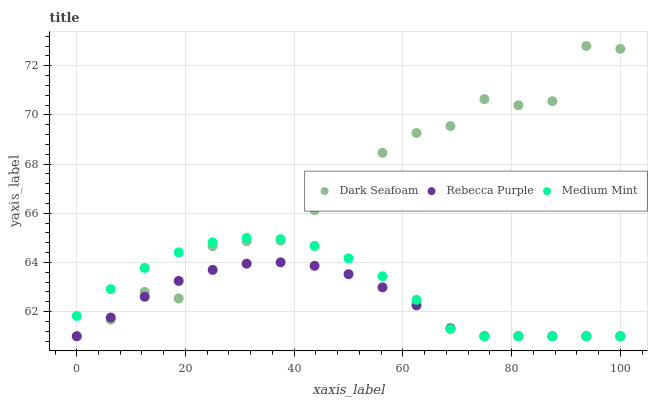Does Rebecca Purple have the minimum area under the curve?
Answer yes or no. Yes. Does Dark Seafoam have the maximum area under the curve?
Answer yes or no. Yes. Does Dark Seafoam have the minimum area under the curve?
Answer yes or no. No. Does Rebecca Purple have the maximum area under the curve?
Answer yes or no. No. Is Rebecca Purple the smoothest?
Answer yes or no. Yes. Is Dark Seafoam the roughest?
Answer yes or no. Yes. Is Dark Seafoam the smoothest?
Answer yes or no. No. Is Rebecca Purple the roughest?
Answer yes or no. No. Does Medium Mint have the lowest value?
Answer yes or no. Yes. Does Dark Seafoam have the highest value?
Answer yes or no. Yes. Does Rebecca Purple have the highest value?
Answer yes or no. No. Does Dark Seafoam intersect Medium Mint?
Answer yes or no. Yes. Is Dark Seafoam less than Medium Mint?
Answer yes or no. No. Is Dark Seafoam greater than Medium Mint?
Answer yes or no. No. 